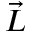<formula> <loc_0><loc_0><loc_500><loc_500>\vec { L }</formula> 